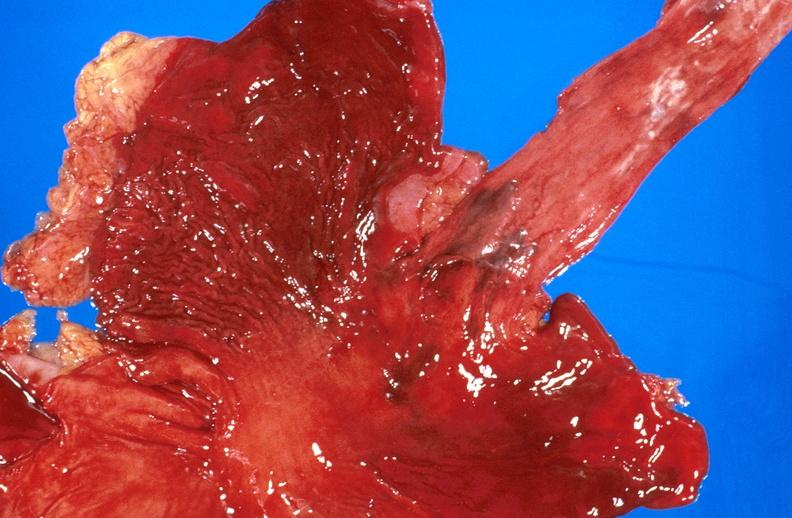what does this image show?
Answer the question using a single word or phrase. Esophageal varices due to alcoholic cirrhosis 